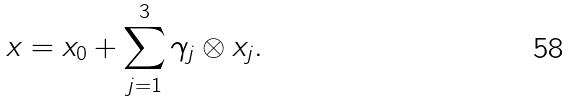<formula> <loc_0><loc_0><loc_500><loc_500>x = x _ { 0 } + \sum _ { j = 1 } ^ { 3 } \gamma _ { j } \otimes x _ { j } .</formula> 